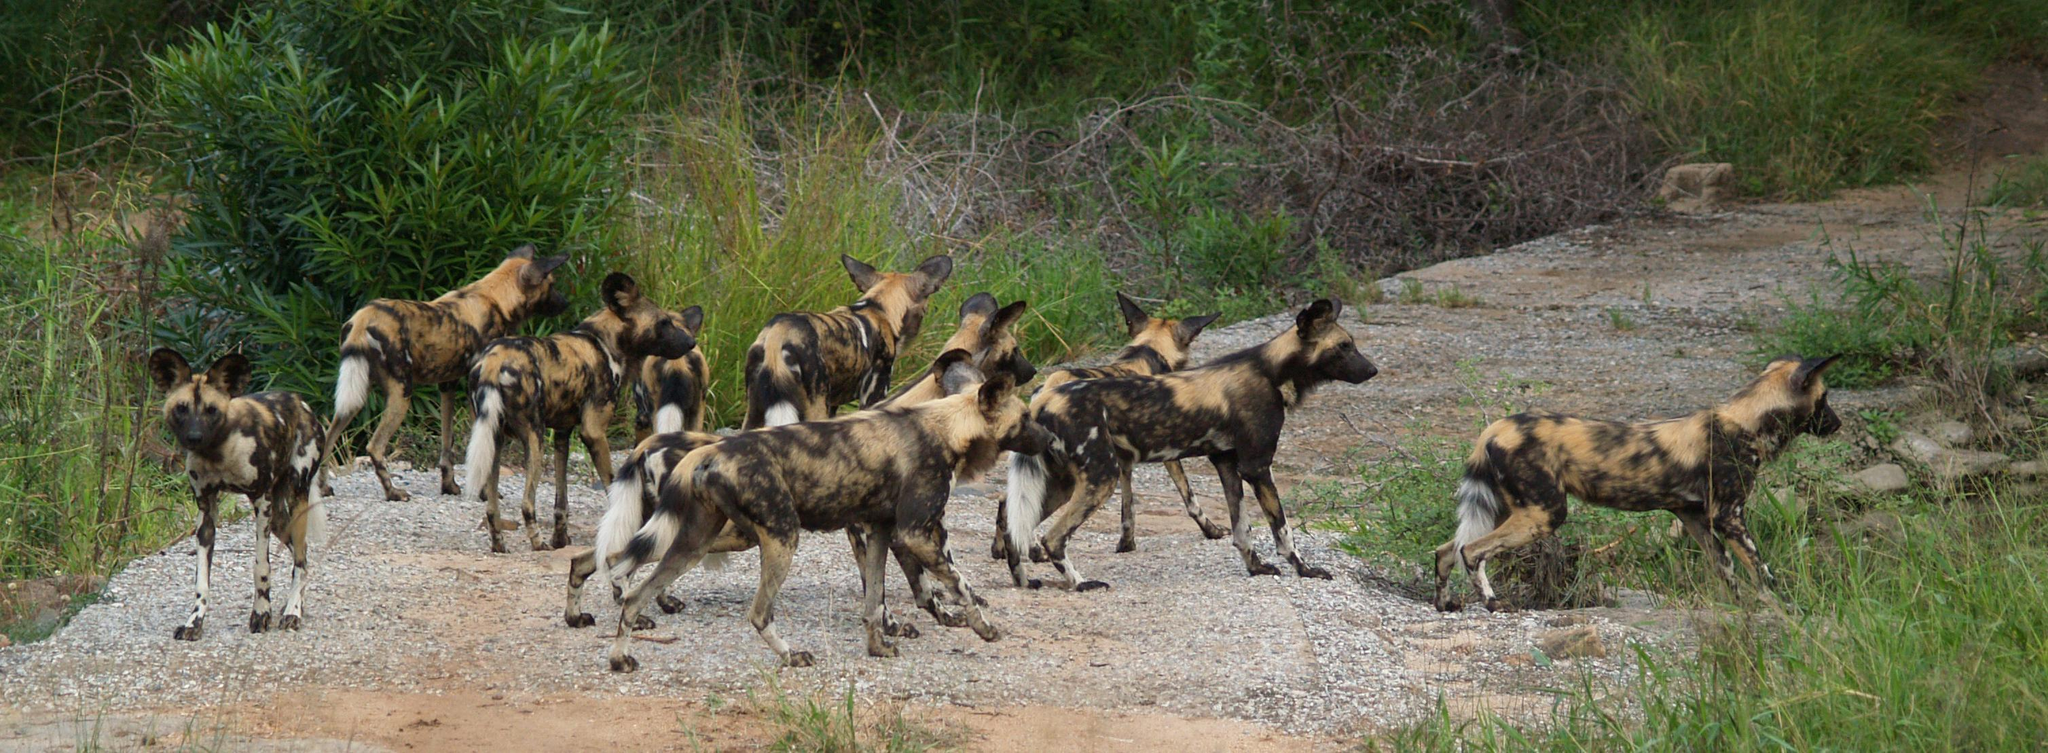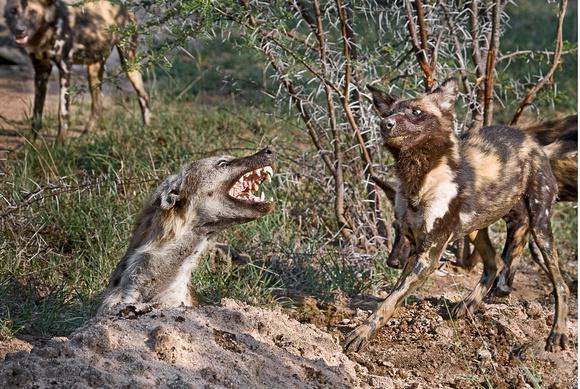The first image is the image on the left, the second image is the image on the right. Given the left and right images, does the statement "In the right image, a fang-baring open-mouthed hyena on the left is facing at least one canine of a different type on the right." hold true? Answer yes or no. Yes. 